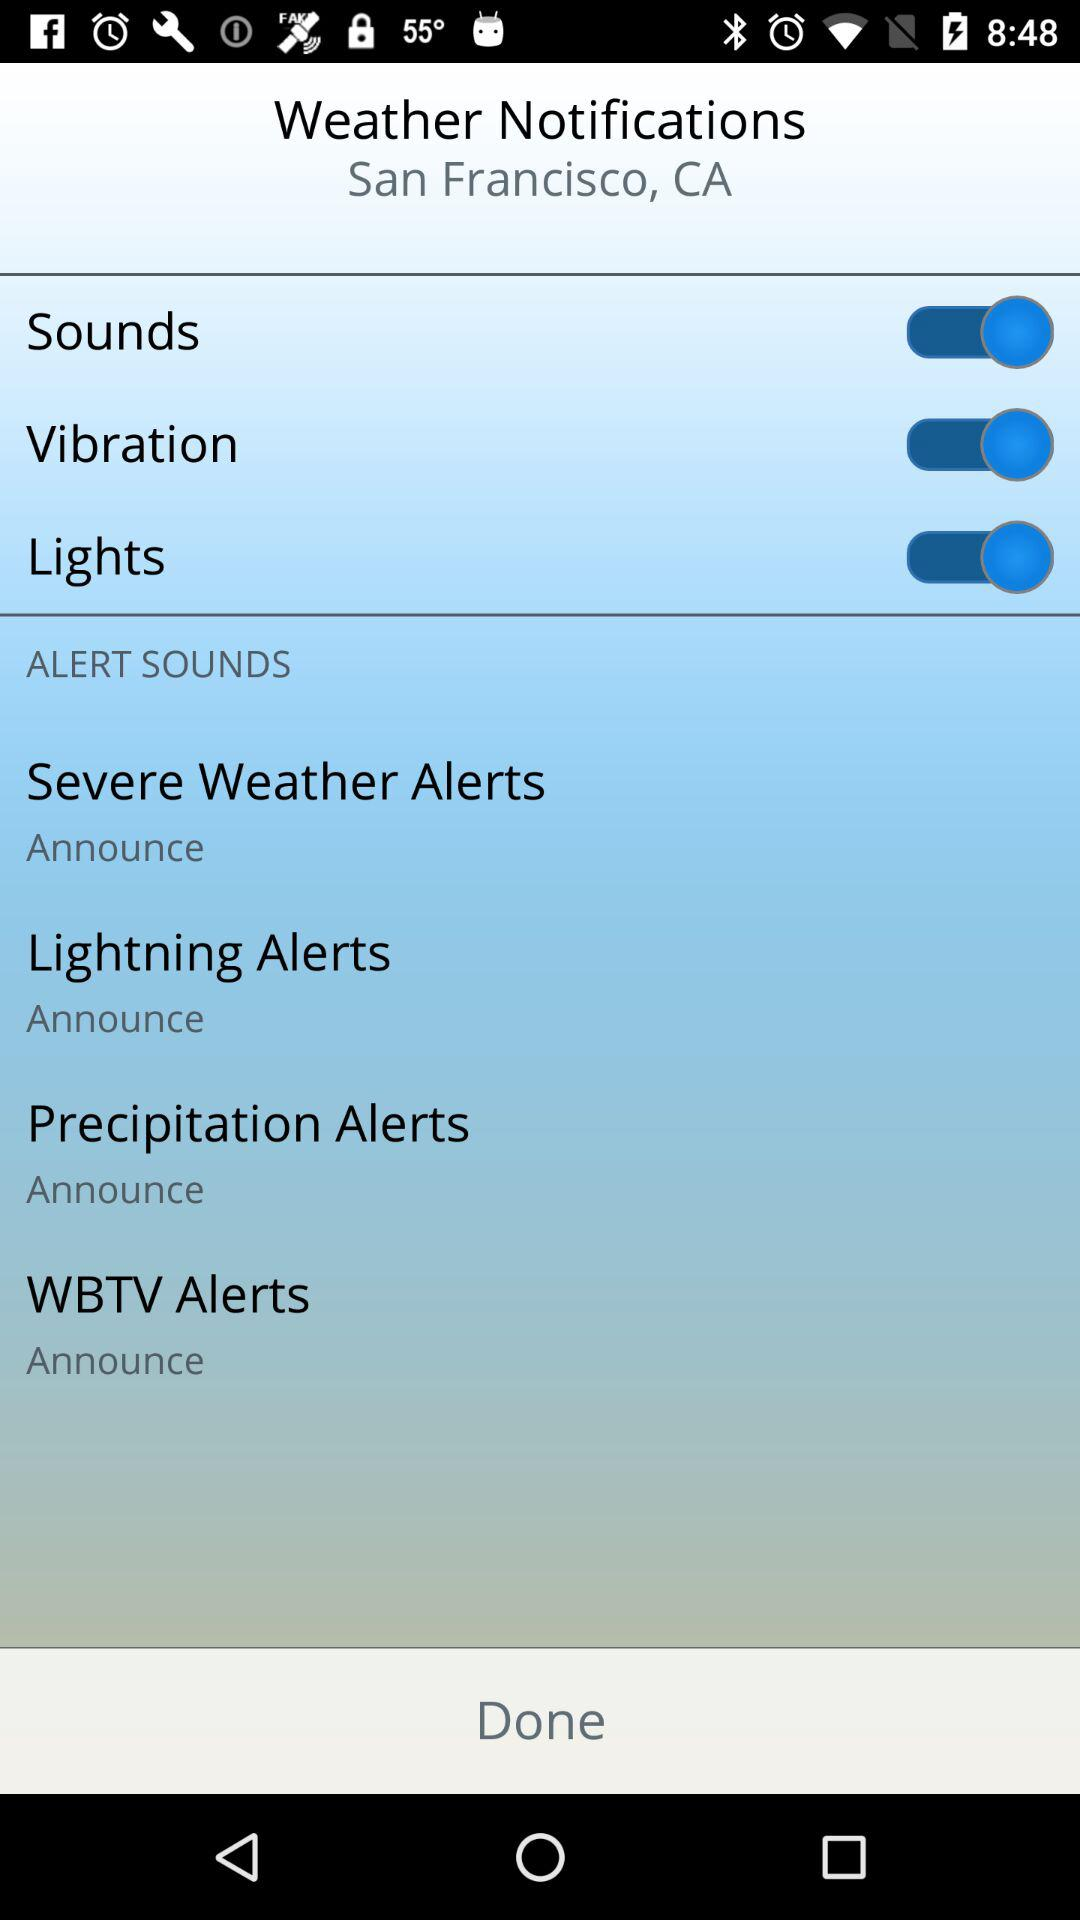How many alert sounds are there?
Answer the question using a single word or phrase. 4 